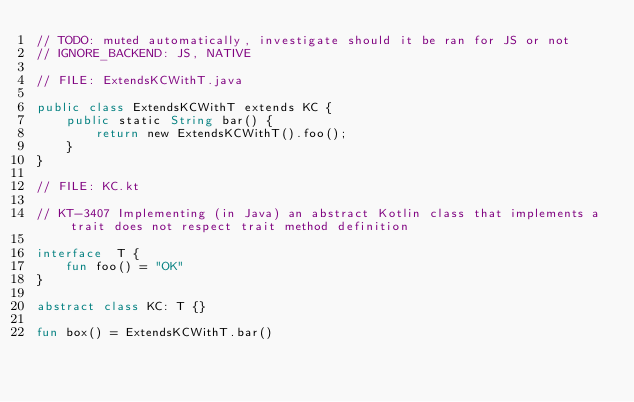Convert code to text. <code><loc_0><loc_0><loc_500><loc_500><_Kotlin_>// TODO: muted automatically, investigate should it be ran for JS or not
// IGNORE_BACKEND: JS, NATIVE

// FILE: ExtendsKCWithT.java

public class ExtendsKCWithT extends KC {
    public static String bar() {
        return new ExtendsKCWithT().foo();
    }
}

// FILE: KC.kt

// KT-3407 Implementing (in Java) an abstract Kotlin class that implements a trait does not respect trait method definition

interface  T {
    fun foo() = "OK"
}

abstract class KC: T {}

fun box() = ExtendsKCWithT.bar()
</code> 